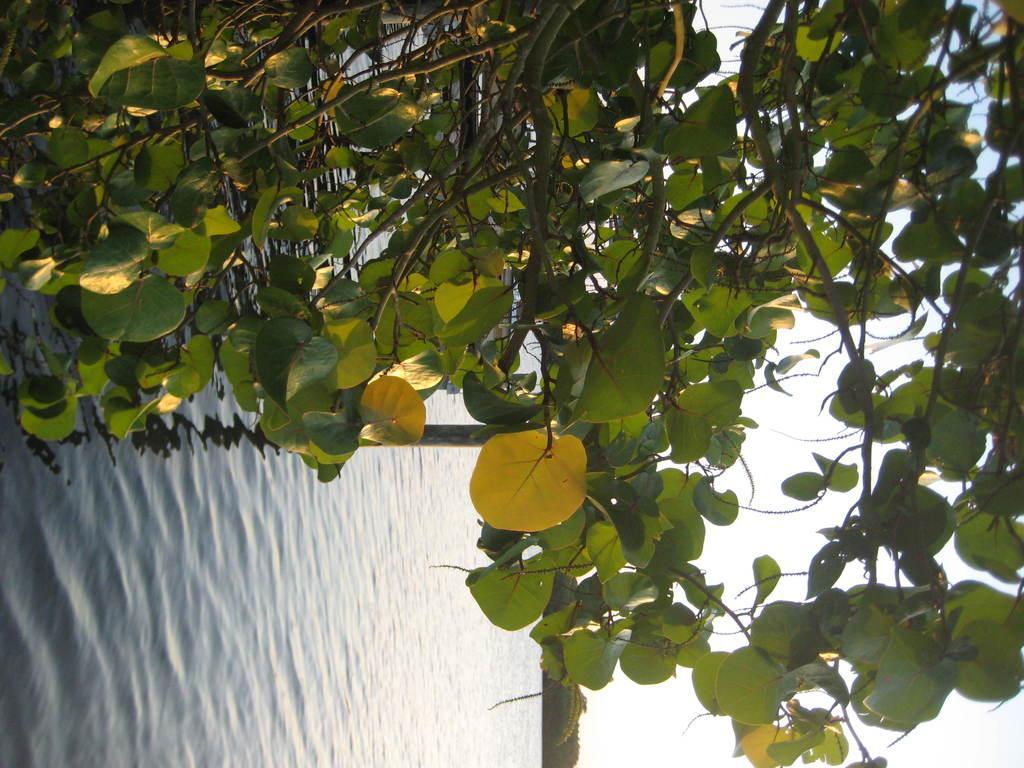Please provide a concise description of this image. In this image we can see the leaves of a tree. Behind the leaves we can see the water. At the bottom we can see the trees. On the right side, we can see the sky. 